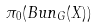<formula> <loc_0><loc_0><loc_500><loc_500>\pi _ { 0 } ( B u n _ { G } ( X ) )</formula> 